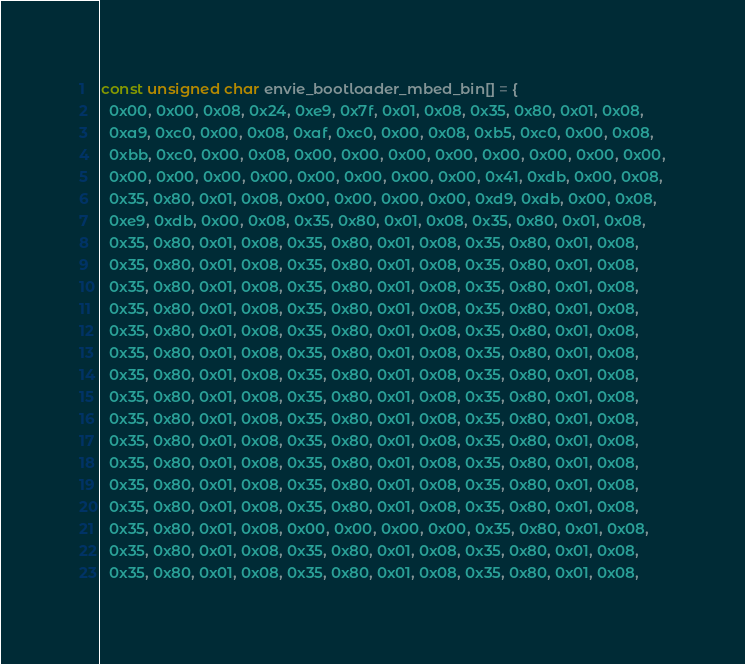<code> <loc_0><loc_0><loc_500><loc_500><_C_>const unsigned char envie_bootloader_mbed_bin[] = {
  0x00, 0x00, 0x08, 0x24, 0xe9, 0x7f, 0x01, 0x08, 0x35, 0x80, 0x01, 0x08,
  0xa9, 0xc0, 0x00, 0x08, 0xaf, 0xc0, 0x00, 0x08, 0xb5, 0xc0, 0x00, 0x08,
  0xbb, 0xc0, 0x00, 0x08, 0x00, 0x00, 0x00, 0x00, 0x00, 0x00, 0x00, 0x00,
  0x00, 0x00, 0x00, 0x00, 0x00, 0x00, 0x00, 0x00, 0x41, 0xdb, 0x00, 0x08,
  0x35, 0x80, 0x01, 0x08, 0x00, 0x00, 0x00, 0x00, 0xd9, 0xdb, 0x00, 0x08,
  0xe9, 0xdb, 0x00, 0x08, 0x35, 0x80, 0x01, 0x08, 0x35, 0x80, 0x01, 0x08,
  0x35, 0x80, 0x01, 0x08, 0x35, 0x80, 0x01, 0x08, 0x35, 0x80, 0x01, 0x08,
  0x35, 0x80, 0x01, 0x08, 0x35, 0x80, 0x01, 0x08, 0x35, 0x80, 0x01, 0x08,
  0x35, 0x80, 0x01, 0x08, 0x35, 0x80, 0x01, 0x08, 0x35, 0x80, 0x01, 0x08,
  0x35, 0x80, 0x01, 0x08, 0x35, 0x80, 0x01, 0x08, 0x35, 0x80, 0x01, 0x08,
  0x35, 0x80, 0x01, 0x08, 0x35, 0x80, 0x01, 0x08, 0x35, 0x80, 0x01, 0x08,
  0x35, 0x80, 0x01, 0x08, 0x35, 0x80, 0x01, 0x08, 0x35, 0x80, 0x01, 0x08,
  0x35, 0x80, 0x01, 0x08, 0x35, 0x80, 0x01, 0x08, 0x35, 0x80, 0x01, 0x08,
  0x35, 0x80, 0x01, 0x08, 0x35, 0x80, 0x01, 0x08, 0x35, 0x80, 0x01, 0x08,
  0x35, 0x80, 0x01, 0x08, 0x35, 0x80, 0x01, 0x08, 0x35, 0x80, 0x01, 0x08,
  0x35, 0x80, 0x01, 0x08, 0x35, 0x80, 0x01, 0x08, 0x35, 0x80, 0x01, 0x08,
  0x35, 0x80, 0x01, 0x08, 0x35, 0x80, 0x01, 0x08, 0x35, 0x80, 0x01, 0x08,
  0x35, 0x80, 0x01, 0x08, 0x35, 0x80, 0x01, 0x08, 0x35, 0x80, 0x01, 0x08,
  0x35, 0x80, 0x01, 0x08, 0x35, 0x80, 0x01, 0x08, 0x35, 0x80, 0x01, 0x08,
  0x35, 0x80, 0x01, 0x08, 0x00, 0x00, 0x00, 0x00, 0x35, 0x80, 0x01, 0x08,
  0x35, 0x80, 0x01, 0x08, 0x35, 0x80, 0x01, 0x08, 0x35, 0x80, 0x01, 0x08,
  0x35, 0x80, 0x01, 0x08, 0x35, 0x80, 0x01, 0x08, 0x35, 0x80, 0x01, 0x08,</code> 